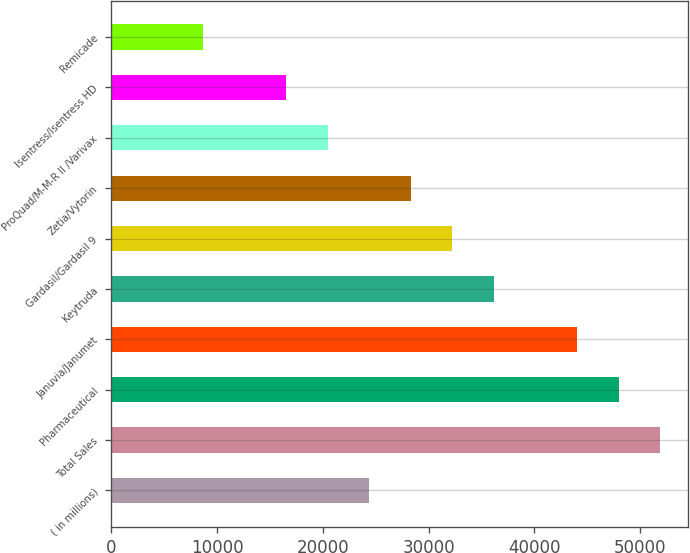Convert chart to OTSL. <chart><loc_0><loc_0><loc_500><loc_500><bar_chart><fcel>( in millions)<fcel>Total Sales<fcel>Pharmaceutical<fcel>Januvia/Janumet<fcel>Keytruda<fcel>Gardasil/Gardasil 9<fcel>Zetia/Vytorin<fcel>ProQuad/M-M-R II /Varivax<fcel>Isentress/Isentress HD<fcel>Remicade<nl><fcel>24400.8<fcel>51912.9<fcel>47982.6<fcel>44052.3<fcel>36191.7<fcel>32261.4<fcel>28331.1<fcel>20470.5<fcel>16540.2<fcel>8679.6<nl></chart> 